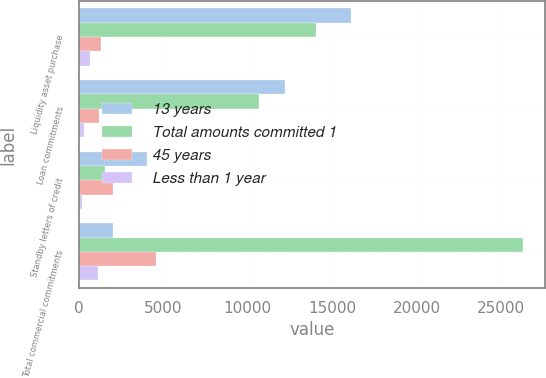Convert chart. <chart><loc_0><loc_0><loc_500><loc_500><stacked_bar_chart><ecel><fcel>Liquidity asset purchase<fcel>Loan commitments<fcel>Standby letters of credit<fcel>Total commercial commitments<nl><fcel>13 years<fcel>16135<fcel>12190<fcel>4018<fcel>2058<nl><fcel>Total amounts committed 1<fcel>14066<fcel>10672<fcel>1538<fcel>26276<nl><fcel>45 years<fcel>1336<fcel>1207<fcel>2058<fcel>4601<nl><fcel>Less than 1 year<fcel>675<fcel>300<fcel>187<fcel>1162<nl></chart> 